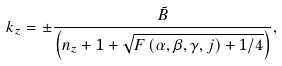Convert formula to latex. <formula><loc_0><loc_0><loc_500><loc_500>k _ { z } = \pm \frac { \tilde { B } } { \left ( n _ { z } + 1 + \sqrt { F \left ( \alpha , \beta , \gamma , j \right ) + 1 / 4 } \right ) } ,</formula> 